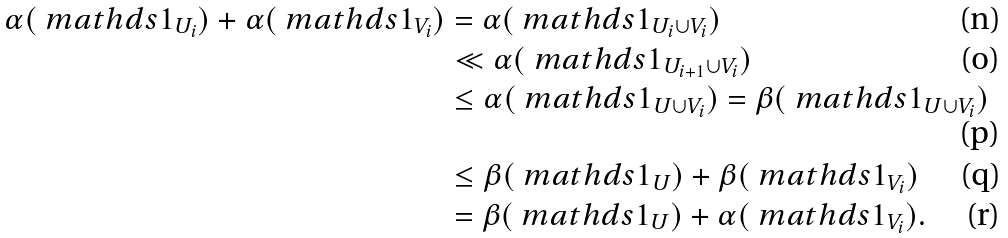Convert formula to latex. <formula><loc_0><loc_0><loc_500><loc_500>\alpha ( \ m a t h d s { 1 } _ { U _ { i } } ) + \alpha ( \ m a t h d s { 1 } _ { V _ { i } } ) & = \alpha ( \ m a t h d s { 1 } _ { U _ { i } \cup V _ { i } } ) \\ & \ll \alpha ( \ m a t h d s { 1 } _ { U _ { i + 1 } \cup V _ { i } } ) \\ & \leq \alpha ( \ m a t h d s { 1 } _ { U \cup V _ { i } } ) = \beta ( \ m a t h d s { 1 } _ { U \cup V _ { i } } ) \\ & \leq \beta ( \ m a t h d s { 1 } _ { U } ) + \beta ( \ m a t h d s { 1 } _ { V _ { i } } ) \\ & = \beta ( \ m a t h d s { 1 } _ { U } ) + \alpha ( \ m a t h d s { 1 } _ { V _ { i } } ) .</formula> 